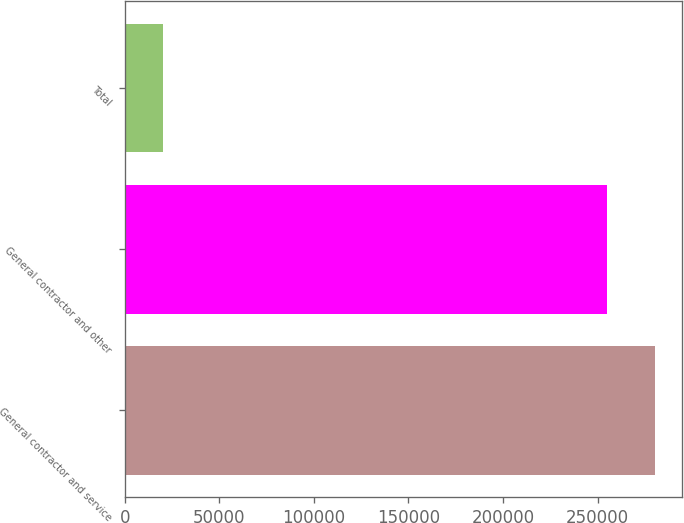<chart> <loc_0><loc_0><loc_500><loc_500><bar_chart><fcel>General contractor and service<fcel>General contractor and other<fcel>Total<nl><fcel>280357<fcel>254870<fcel>20201<nl></chart> 